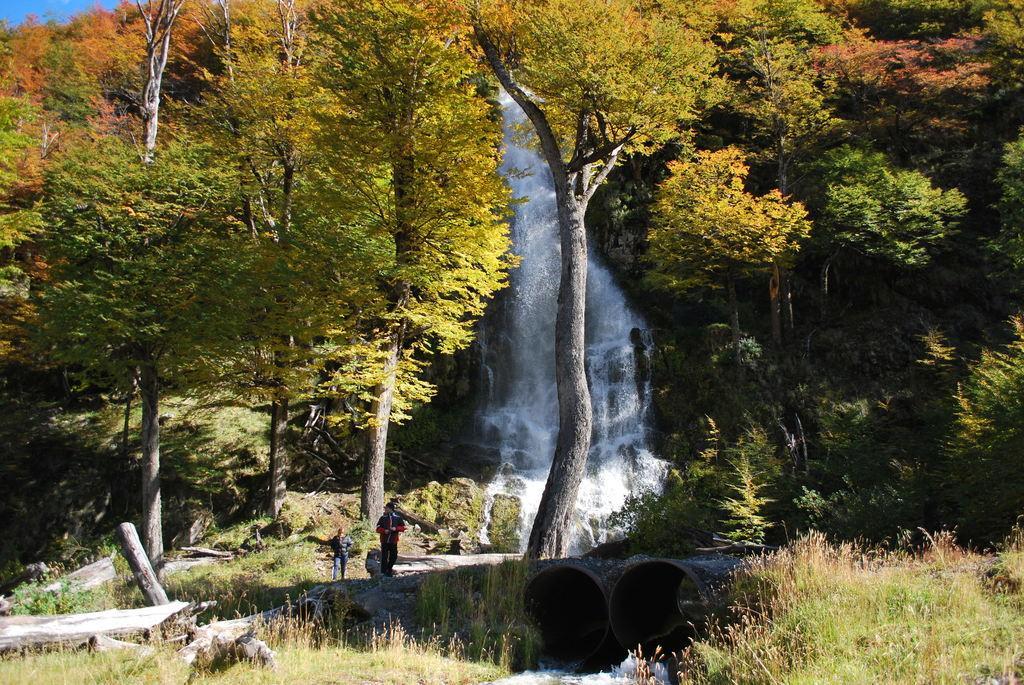Could you give a brief overview of what you see in this image? In this image I can see two huge pipes, water coming from the pipes, some grass on the ground, two persons standing and few trees which are green and orange in color. I can see the waterfall and the sky. 